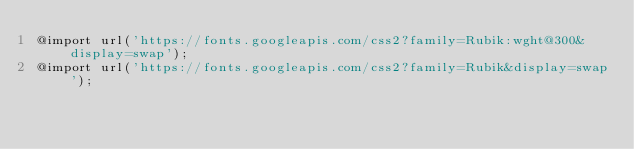<code> <loc_0><loc_0><loc_500><loc_500><_CSS_>@import url('https://fonts.googleapis.com/css2?family=Rubik:wght@300&display=swap');
@import url('https://fonts.googleapis.com/css2?family=Rubik&display=swap');</code> 